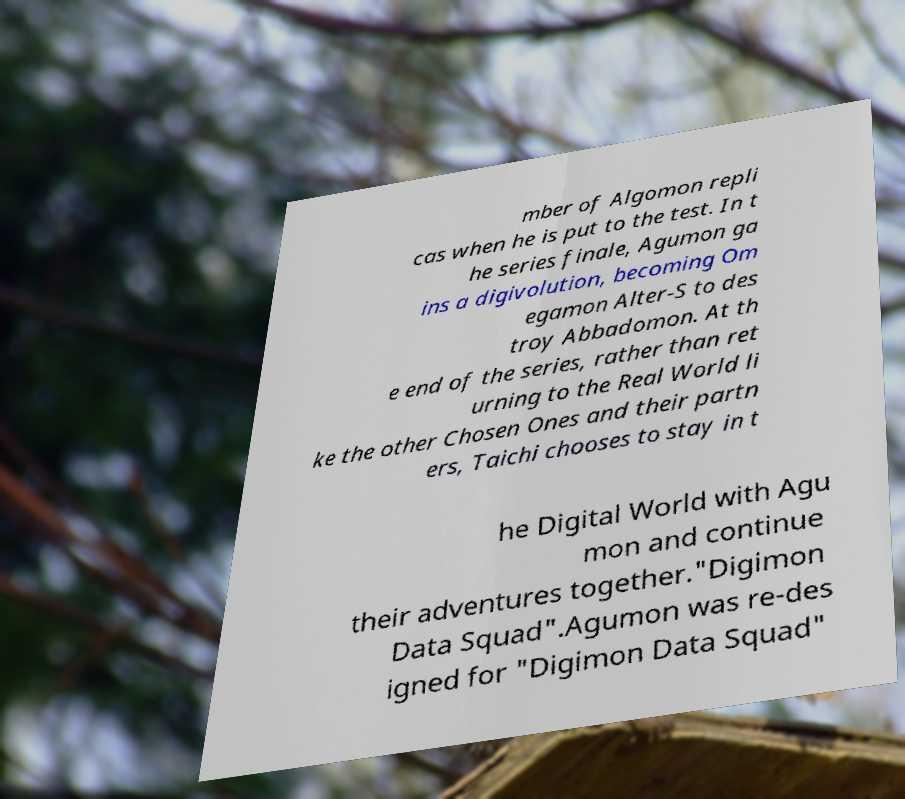Please read and relay the text visible in this image. What does it say? mber of Algomon repli cas when he is put to the test. In t he series finale, Agumon ga ins a digivolution, becoming Om egamon Alter-S to des troy Abbadomon. At th e end of the series, rather than ret urning to the Real World li ke the other Chosen Ones and their partn ers, Taichi chooses to stay in t he Digital World with Agu mon and continue their adventures together."Digimon Data Squad".Agumon was re-des igned for "Digimon Data Squad" 